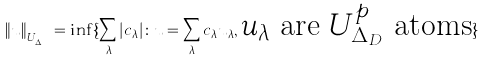Convert formula to latex. <formula><loc_0><loc_0><loc_500><loc_500>\| u \| _ { U _ { \Delta _ { D } } ^ { p } } = \inf \{ \sum _ { \lambda } | c _ { \lambda } | \colon u = \sum _ { \lambda } c _ { \lambda } u _ { \lambda } , \text {$u_{\lambda}$ are $U_{\Delta_{D}}^{p}$ atoms} \}</formula> 